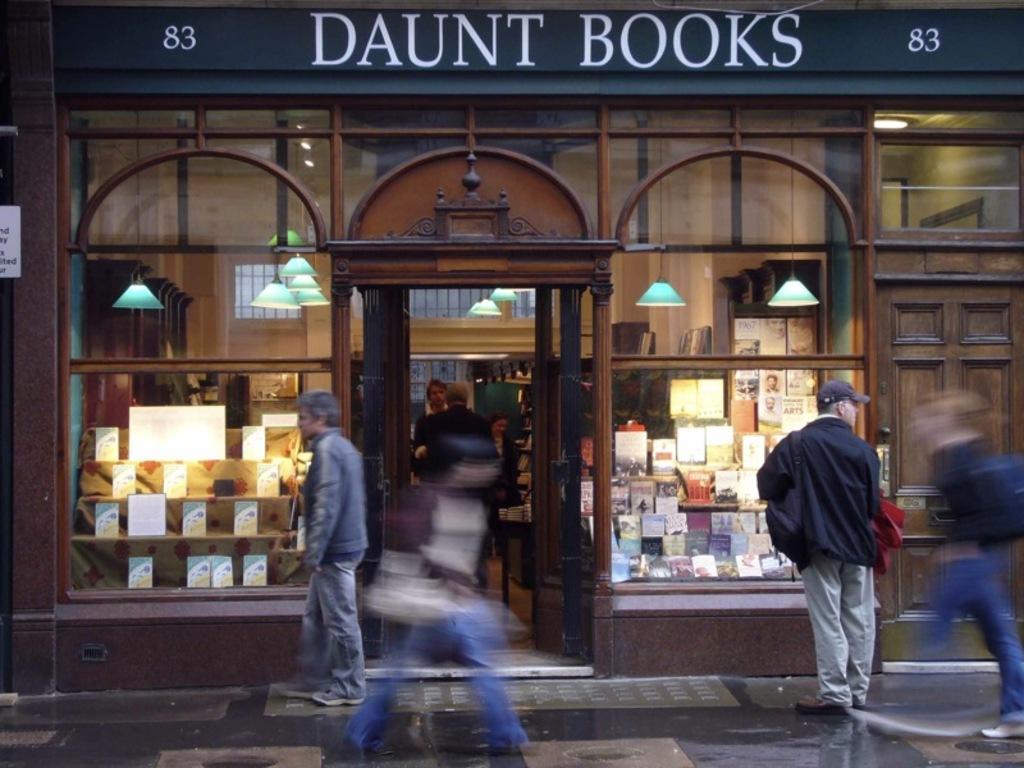Describe this image in one or two sentences. In this picture we can see some people, there is a store in the background, on the right side and left side we can see books, there are some lights in the middle, there is some text at the top of the picture. 